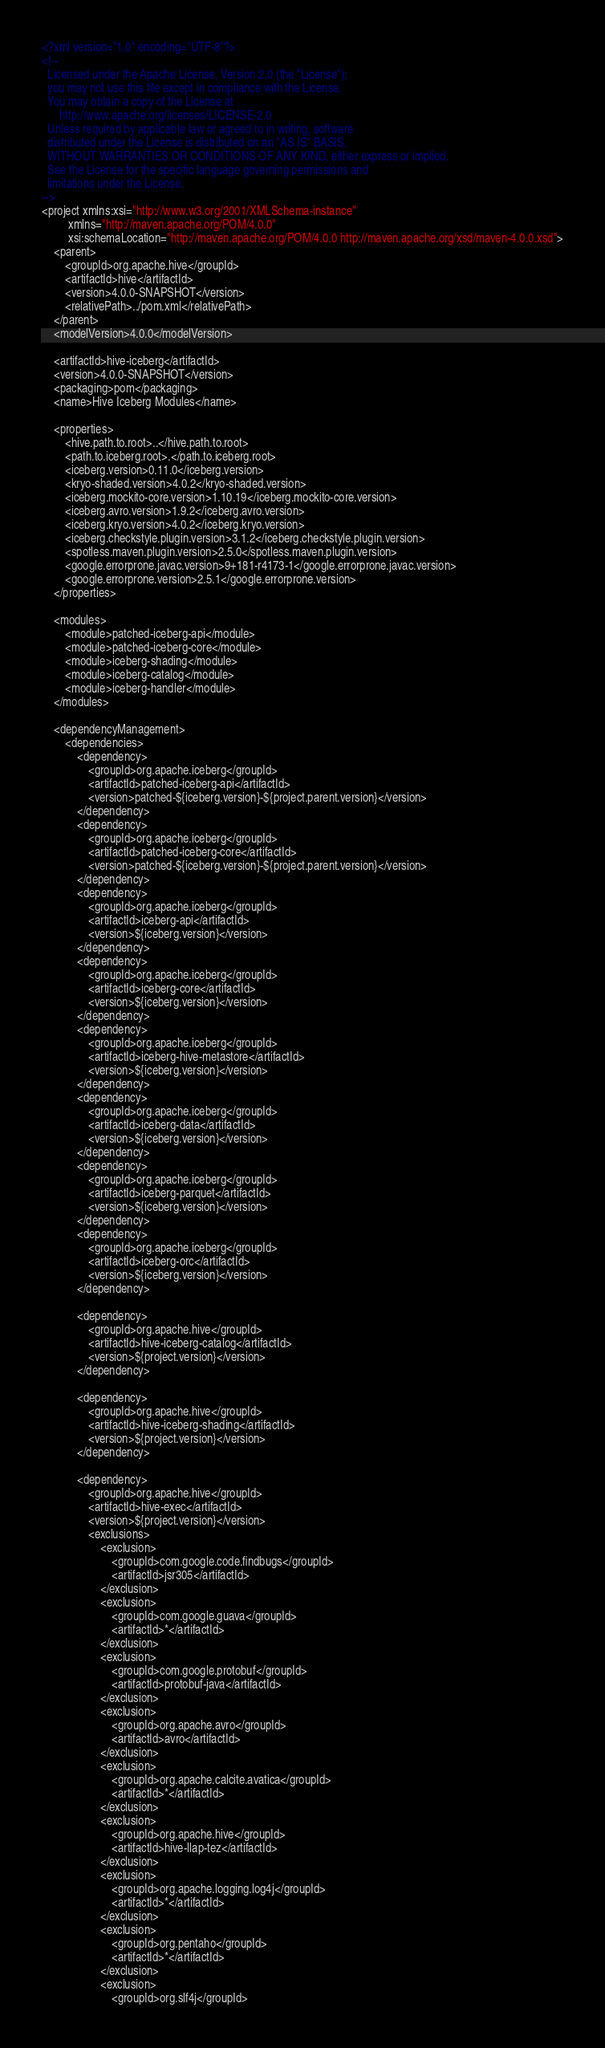Convert code to text. <code><loc_0><loc_0><loc_500><loc_500><_XML_><?xml version="1.0" encoding="UTF-8"?>
<!--
  Licensed under the Apache License, Version 2.0 (the "License");
  you may not use this file except in compliance with the License.
  You may obtain a copy of the License at
      http://www.apache.org/licenses/LICENSE-2.0
  Unless required by applicable law or agreed to in writing, software
  distributed under the License is distributed on an "AS IS" BASIS,
  WITHOUT WARRANTIES OR CONDITIONS OF ANY KIND, either express or implied.
  See the License for the specific language governing permissions and
  limitations under the License.
-->
<project xmlns:xsi="http://www.w3.org/2001/XMLSchema-instance"
         xmlns="http://maven.apache.org/POM/4.0.0"
         xsi:schemaLocation="http://maven.apache.org/POM/4.0.0 http://maven.apache.org/xsd/maven-4.0.0.xsd">
    <parent>
        <groupId>org.apache.hive</groupId>
        <artifactId>hive</artifactId>
        <version>4.0.0-SNAPSHOT</version>
        <relativePath>../pom.xml</relativePath>
    </parent>
    <modelVersion>4.0.0</modelVersion>

    <artifactId>hive-iceberg</artifactId>
    <version>4.0.0-SNAPSHOT</version>
    <packaging>pom</packaging>
    <name>Hive Iceberg Modules</name>

    <properties>
        <hive.path.to.root>..</hive.path.to.root>
        <path.to.iceberg.root>.</path.to.iceberg.root>
        <iceberg.version>0.11.0</iceberg.version>
        <kryo-shaded.version>4.0.2</kryo-shaded.version>
        <iceberg.mockito-core.version>1.10.19</iceberg.mockito-core.version>
        <iceberg.avro.version>1.9.2</iceberg.avro.version>
        <iceberg.kryo.version>4.0.2</iceberg.kryo.version>
        <iceberg.checkstyle.plugin.version>3.1.2</iceberg.checkstyle.plugin.version>
        <spotless.maven.plugin.version>2.5.0</spotless.maven.plugin.version>
        <google.errorprone.javac.version>9+181-r4173-1</google.errorprone.javac.version>
        <google.errorprone.version>2.5.1</google.errorprone.version>
    </properties>

    <modules>
        <module>patched-iceberg-api</module>
        <module>patched-iceberg-core</module>
        <module>iceberg-shading</module>
        <module>iceberg-catalog</module>
        <module>iceberg-handler</module>
    </modules>

    <dependencyManagement>
        <dependencies>
            <dependency>
                <groupId>org.apache.iceberg</groupId>
                <artifactId>patched-iceberg-api</artifactId>
                <version>patched-${iceberg.version}-${project.parent.version}</version>
            </dependency>
            <dependency>
                <groupId>org.apache.iceberg</groupId>
                <artifactId>patched-iceberg-core</artifactId>
                <version>patched-${iceberg.version}-${project.parent.version}</version>
            </dependency>
            <dependency>
                <groupId>org.apache.iceberg</groupId>
                <artifactId>iceberg-api</artifactId>
                <version>${iceberg.version}</version>
            </dependency>
            <dependency>
                <groupId>org.apache.iceberg</groupId>
                <artifactId>iceberg-core</artifactId>
                <version>${iceberg.version}</version>
            </dependency>
            <dependency>
                <groupId>org.apache.iceberg</groupId>
                <artifactId>iceberg-hive-metastore</artifactId>
                <version>${iceberg.version}</version>
            </dependency>
            <dependency>
                <groupId>org.apache.iceberg</groupId>
                <artifactId>iceberg-data</artifactId>
                <version>${iceberg.version}</version>
            </dependency>
            <dependency>
                <groupId>org.apache.iceberg</groupId>
                <artifactId>iceberg-parquet</artifactId>
                <version>${iceberg.version}</version>
            </dependency>
            <dependency>
                <groupId>org.apache.iceberg</groupId>
                <artifactId>iceberg-orc</artifactId>
                <version>${iceberg.version}</version>
            </dependency>

            <dependency>
                <groupId>org.apache.hive</groupId>
                <artifactId>hive-iceberg-catalog</artifactId>
                <version>${project.version}</version>
            </dependency>

            <dependency>
                <groupId>org.apache.hive</groupId>
                <artifactId>hive-iceberg-shading</artifactId>
                <version>${project.version}</version>
            </dependency>

            <dependency>
                <groupId>org.apache.hive</groupId>
                <artifactId>hive-exec</artifactId>
                <version>${project.version}</version>
                <exclusions>
                    <exclusion>
                        <groupId>com.google.code.findbugs</groupId>
                        <artifactId>jsr305</artifactId>
                    </exclusion>
                    <exclusion>
                        <groupId>com.google.guava</groupId>
                        <artifactId>*</artifactId>
                    </exclusion>
                    <exclusion>
                        <groupId>com.google.protobuf</groupId>
                        <artifactId>protobuf-java</artifactId>
                    </exclusion>
                    <exclusion>
                        <groupId>org.apache.avro</groupId>
                        <artifactId>avro</artifactId>
                    </exclusion>
                    <exclusion>
                        <groupId>org.apache.calcite.avatica</groupId>
                        <artifactId>*</artifactId>
                    </exclusion>
                    <exclusion>
                        <groupId>org.apache.hive</groupId>
                        <artifactId>hive-llap-tez</artifactId>
                    </exclusion>
                    <exclusion>
                        <groupId>org.apache.logging.log4j</groupId>
                        <artifactId>*</artifactId>
                    </exclusion>
                    <exclusion>
                        <groupId>org.pentaho</groupId>
                        <artifactId>*</artifactId>
                    </exclusion>
                    <exclusion>
                        <groupId>org.slf4j</groupId></code> 